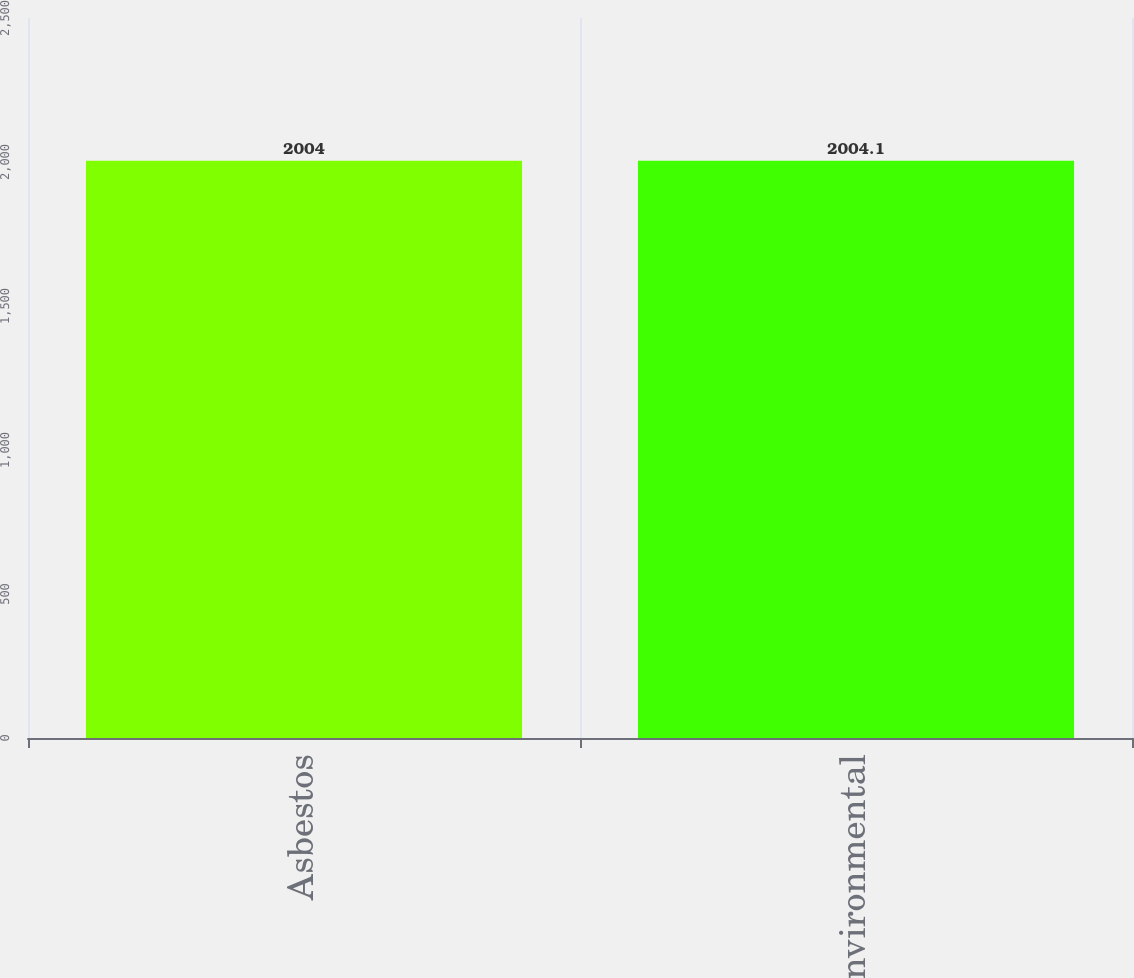Convert chart to OTSL. <chart><loc_0><loc_0><loc_500><loc_500><bar_chart><fcel>Asbestos<fcel>Environmental<nl><fcel>2004<fcel>2004.1<nl></chart> 